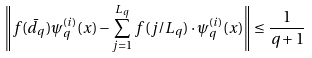Convert formula to latex. <formula><loc_0><loc_0><loc_500><loc_500>\left \| f ( \bar { d } _ { q } ) \psi ^ { ( i ) } _ { q } ( x ) - \sum _ { j = 1 } ^ { L _ { q } } f ( j / L _ { q } ) \cdot \psi ^ { ( i ) } _ { q } ( x ) \right \| \leq \frac { 1 } { q + 1 }</formula> 